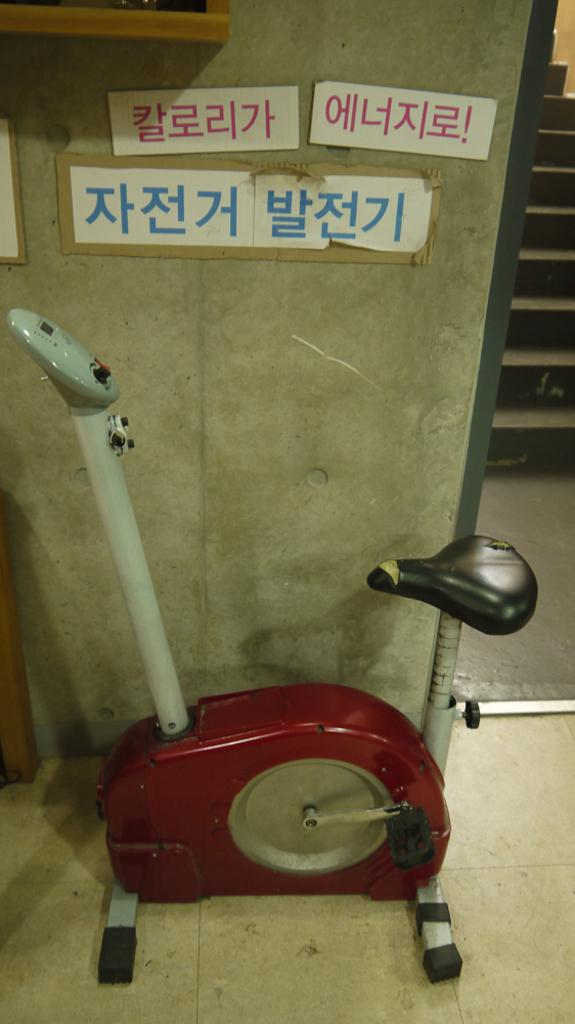<image>
Provide a brief description of the given image. An exercise bike with no handle bar has signs written in Korean above it. 